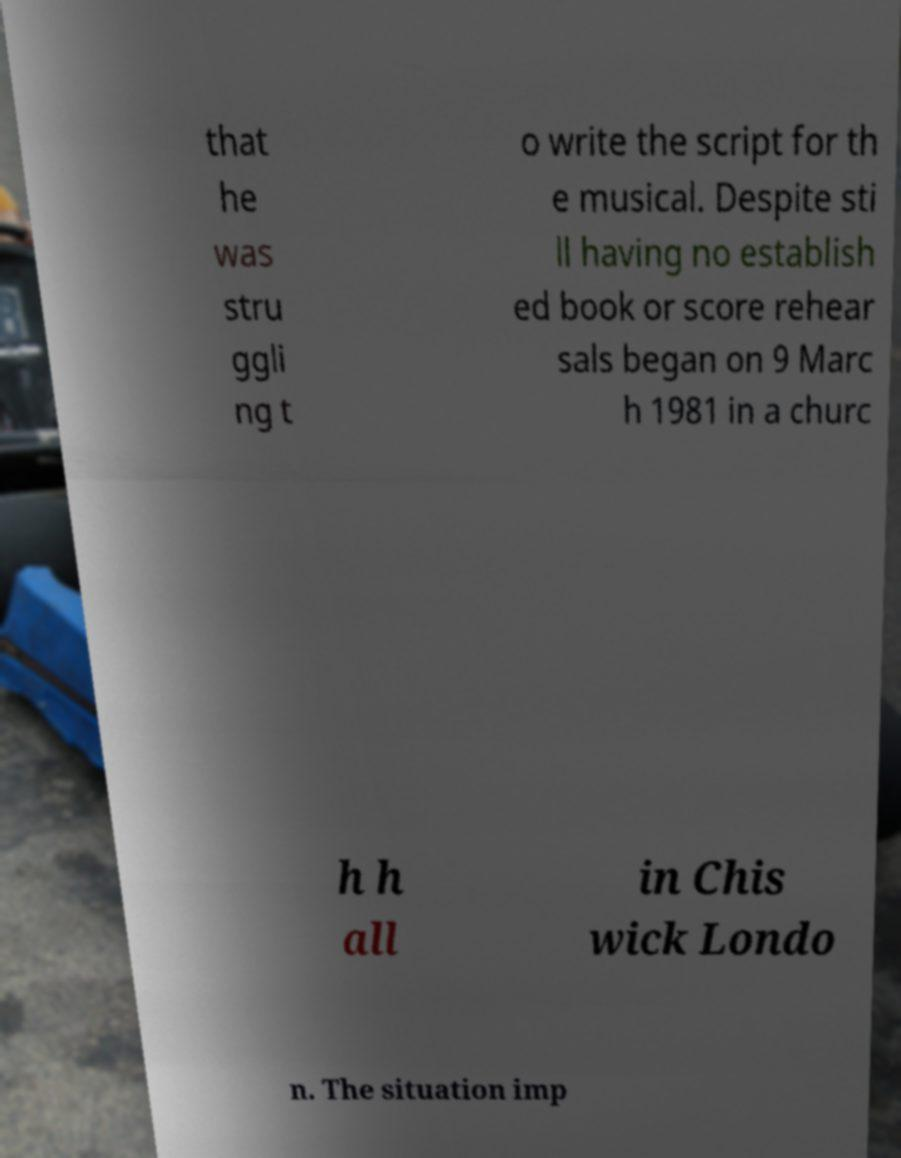Could you assist in decoding the text presented in this image and type it out clearly? that he was stru ggli ng t o write the script for th e musical. Despite sti ll having no establish ed book or score rehear sals began on 9 Marc h 1981 in a churc h h all in Chis wick Londo n. The situation imp 